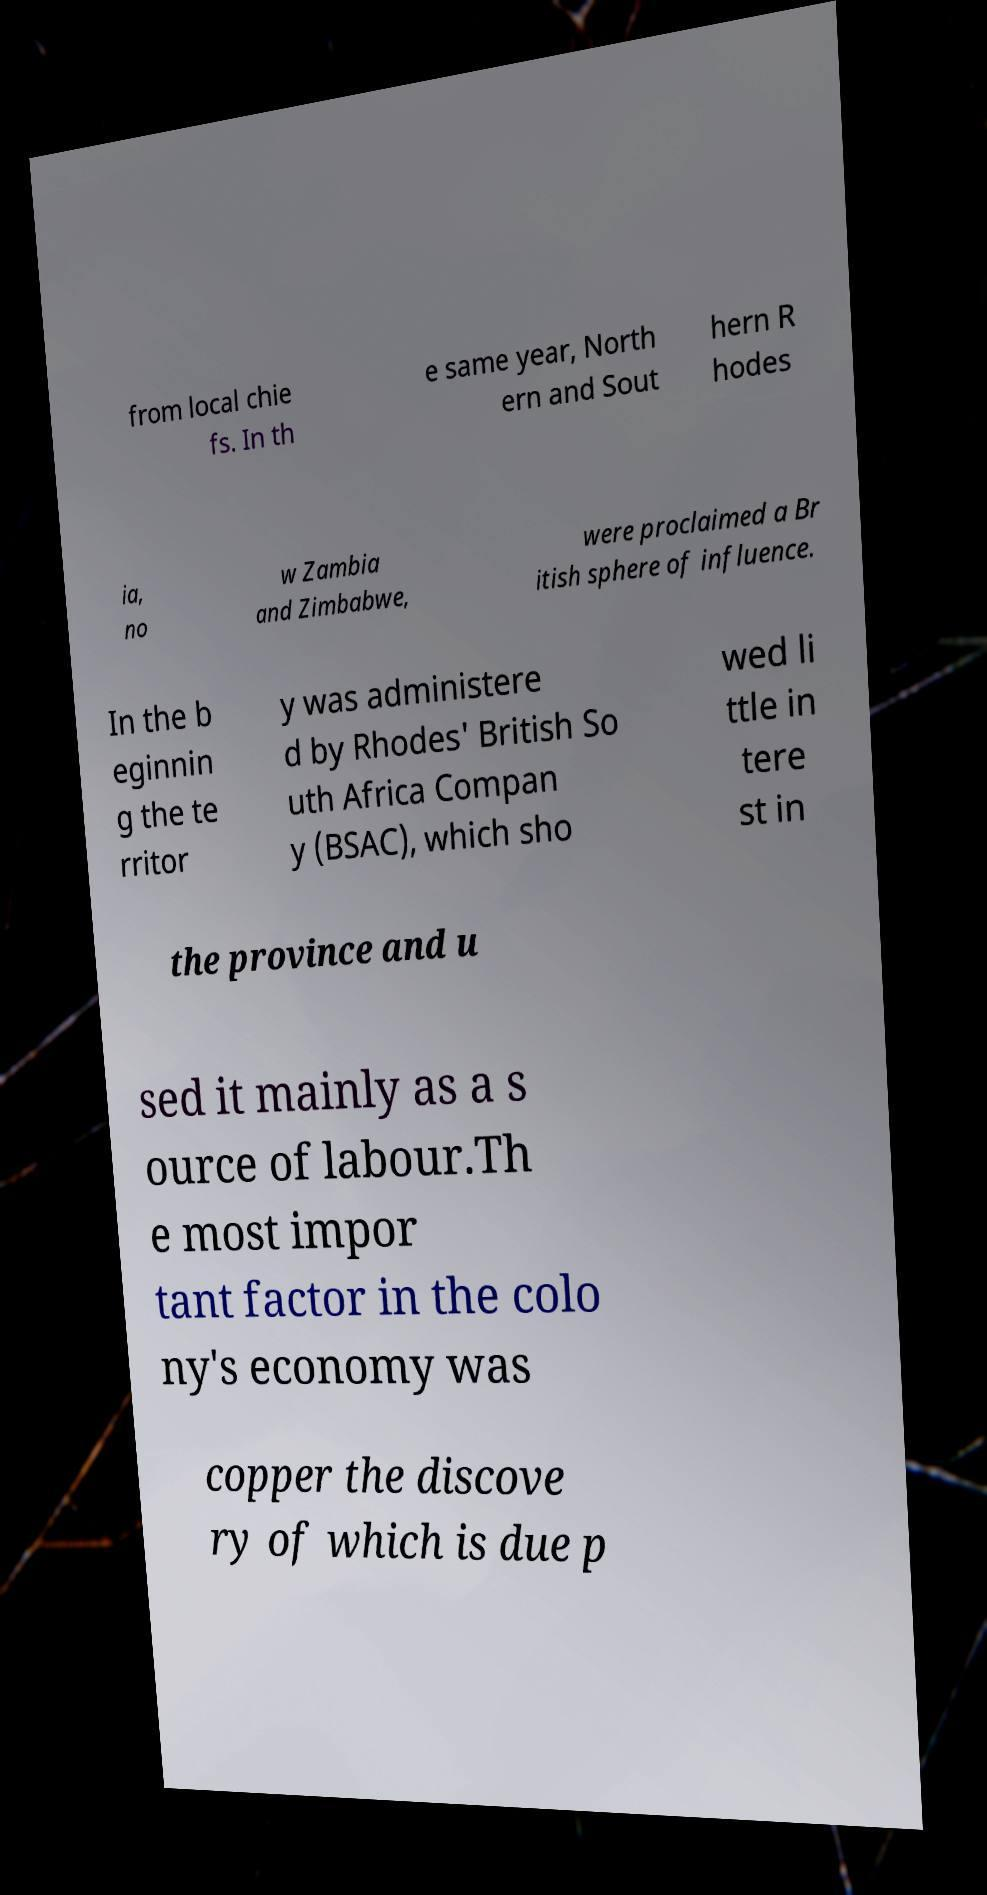Can you read and provide the text displayed in the image?This photo seems to have some interesting text. Can you extract and type it out for me? from local chie fs. In th e same year, North ern and Sout hern R hodes ia, no w Zambia and Zimbabwe, were proclaimed a Br itish sphere of influence. In the b eginnin g the te rritor y was administere d by Rhodes' British So uth Africa Compan y (BSAC), which sho wed li ttle in tere st in the province and u sed it mainly as a s ource of labour.Th e most impor tant factor in the colo ny's economy was copper the discove ry of which is due p 